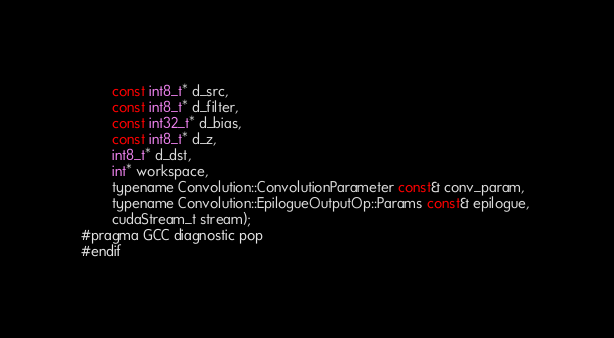Convert code to text. <code><loc_0><loc_0><loc_500><loc_500><_Cuda_>        const int8_t* d_src, 
        const int8_t* d_filter, 
        const int32_t* d_bias, 
        const int8_t* d_z, 
        int8_t* d_dst, 
        int* workspace, 
        typename Convolution::ConvolutionParameter const& conv_param, 
        typename Convolution::EpilogueOutputOp::Params const& epilogue, 
        cudaStream_t stream);
#pragma GCC diagnostic pop
#endif
</code> 